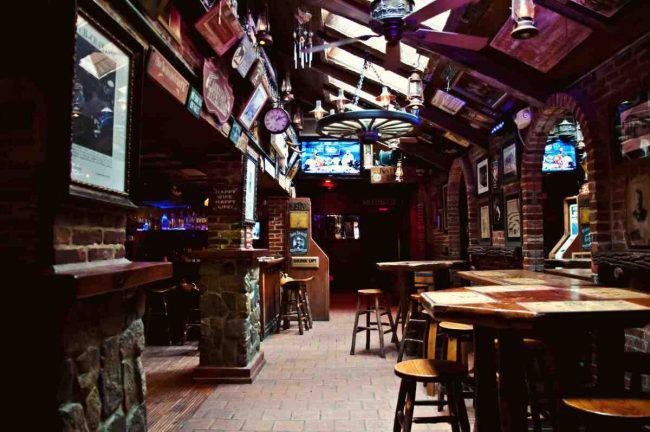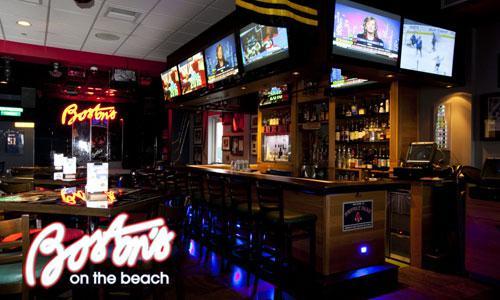The first image is the image on the left, the second image is the image on the right. Considering the images on both sides, is "One image is of the inside of a business and the other is of the outside of a business." valid? Answer yes or no. No. 